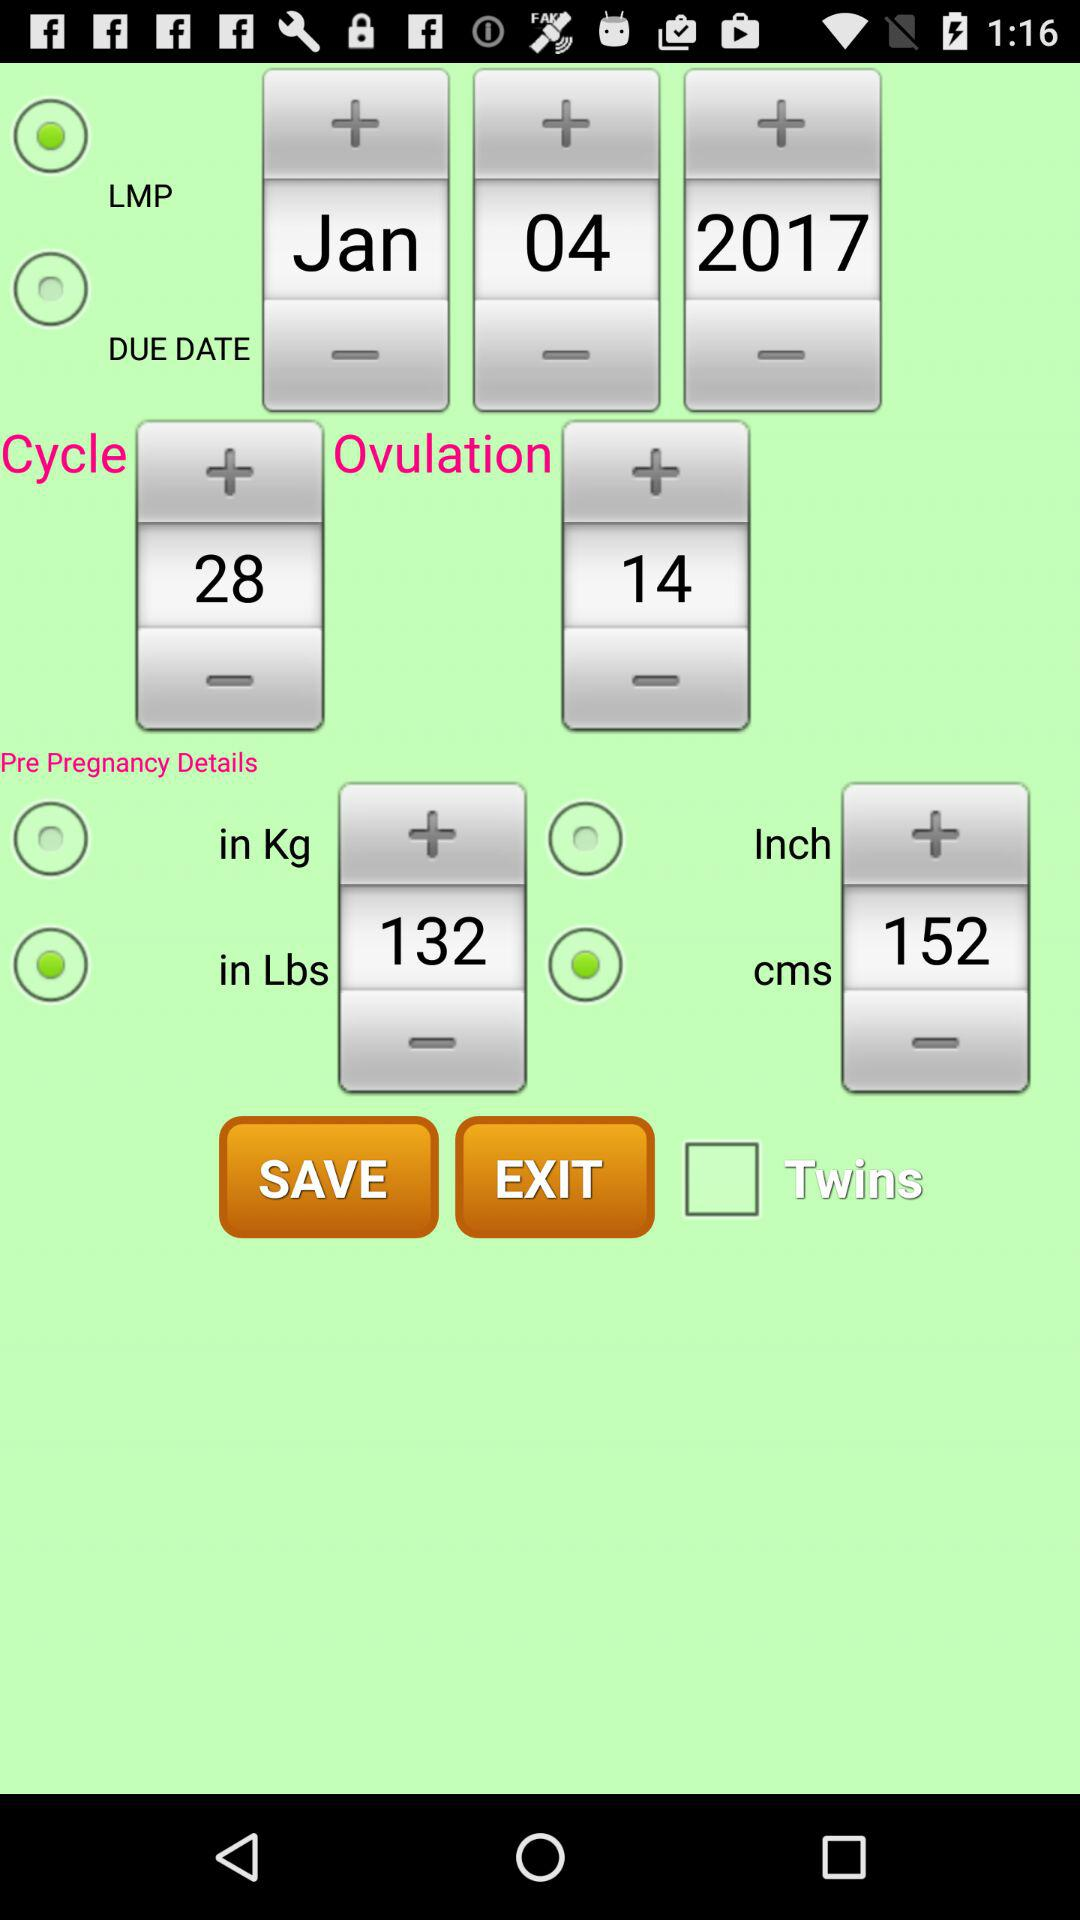Which option is selected out of inches and cms? The selected option is "cms". 